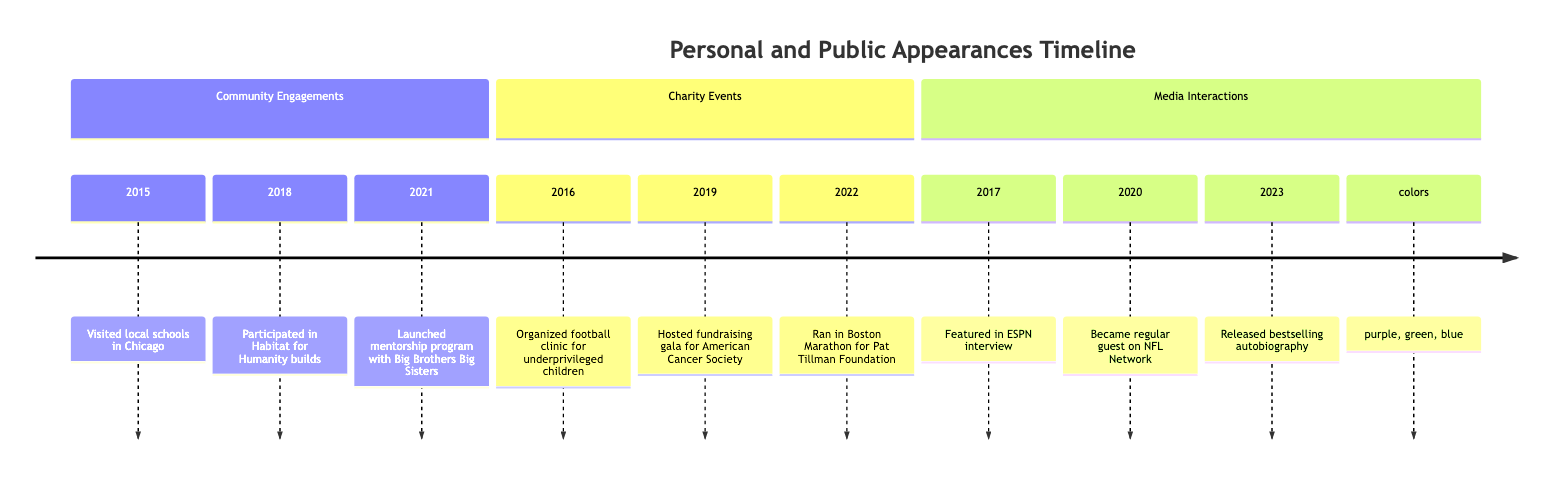What year did you visit local schools in Chicago? According to the timeline, the event "Visited local schools in Chicago" occurred in 2015.
Answer: 2015 How many charity events are listed? The timeline shows three charity events: one in 2016, one in 2019, and one in 2022. Therefore, the total is three.
Answer: 3 What was the fundraising amount for the gala in 2019? The description for the 2019 event mentions that the gala raised over $500,000.
Answer: $500,000 Which event took place in 2020? The 2020 event listed is "Became a regular guest on the NFL Network's 'Good Morning Football'."
Answer: Media Interaction Which organization partnered with you for the football clinic in 2016? The 2016 charity event description states that the football clinic was organized in partnership with the Boys & Girls Clubs of America.
Answer: Boys & Girls Clubs of America What type of events are included in the timeline? The timeline categorizes events into three types: Community Engagements, Charity Events, and Media Interactions.
Answer: Community Engagements, Charity Events, Media Interactions What is the last event listed in the timeline? The final entry in the timeline indicates that in 2023, the event was "Released an autobiography," which serves as the last event.
Answer: Released an autobiography In what year did you launch the mentorship program? The mentorship program was launched in 2021 according to the timeline.
Answer: 2021 What was a community engagement activity you participated in 2018? In 2018, the community engagement activity was "Participated in Habitat for Humanity builds."
Answer: Participated in Habitat for Humanity builds 